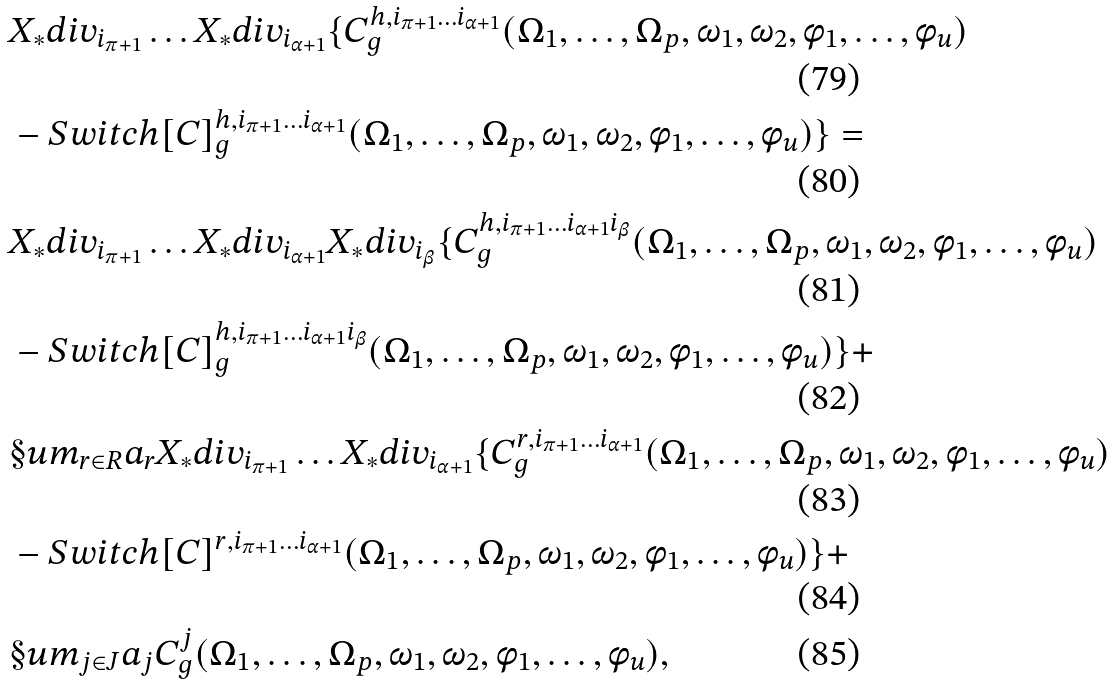Convert formula to latex. <formula><loc_0><loc_0><loc_500><loc_500>& X _ { * } d i v _ { i _ { \pi + 1 } } \dots X _ { * } d i v _ { i _ { \alpha + 1 } } \{ C ^ { h , i _ { \pi + 1 } \dots i _ { \alpha + 1 } } _ { g } ( \Omega _ { 1 } , \dots , \Omega _ { p } , \omega _ { 1 } , \omega _ { 2 } , \phi _ { 1 } , \dots , \phi _ { u } ) \\ & - S w i t c h [ C ] ^ { h , i _ { \pi + 1 } \dots i _ { \alpha + 1 } } _ { g } ( \Omega _ { 1 } , \dots , \Omega _ { p } , \omega _ { 1 } , \omega _ { 2 } , \phi _ { 1 } , \dots , \phi _ { u } ) \} = \\ & X _ { * } d i v _ { i _ { \pi + 1 } } \dots X _ { * } d i v _ { i _ { \alpha + 1 } } X _ { * } d i v _ { i _ { \beta } } \{ C ^ { h , i _ { \pi + 1 } \dots i _ { \alpha + 1 } i _ { \beta } } _ { g } ( \Omega _ { 1 } , \dots , \Omega _ { p } , \omega _ { 1 } , \omega _ { 2 } , \phi _ { 1 } , \dots , \phi _ { u } ) \\ & - S w i t c h [ C ] ^ { h , i _ { \pi + 1 } \dots i _ { \alpha + 1 } i _ { \beta } } _ { g } ( \Omega _ { 1 } , \dots , \Omega _ { p } , \omega _ { 1 } , \omega _ { 2 } , \phi _ { 1 } , \dots , \phi _ { u } ) \} + \\ & \S u m _ { r \in R } a _ { r } X _ { * } d i v _ { i _ { \pi + 1 } } \dots X _ { * } d i v _ { i _ { \alpha + 1 } } \{ C ^ { r , i _ { \pi + 1 } \dots i _ { \alpha + 1 } } _ { g } ( \Omega _ { 1 } , \dots , \Omega _ { p } , \omega _ { 1 } , \omega _ { 2 } , \phi _ { 1 } , \dots , \phi _ { u } ) \\ & - S w i t c h [ C ] ^ { r , i _ { \pi + 1 } \dots i _ { \alpha + 1 } } ( \Omega _ { 1 } , \dots , \Omega _ { p } , \omega _ { 1 } , \omega _ { 2 } , \phi _ { 1 } , \dots , \phi _ { u } ) \} + \\ & \S u m _ { j \in J } a _ { j } C ^ { j } _ { g } ( \Omega _ { 1 } , \dots , \Omega _ { p } , \omega _ { 1 } , \omega _ { 2 } , \phi _ { 1 } , \dots , \phi _ { u } ) ,</formula> 